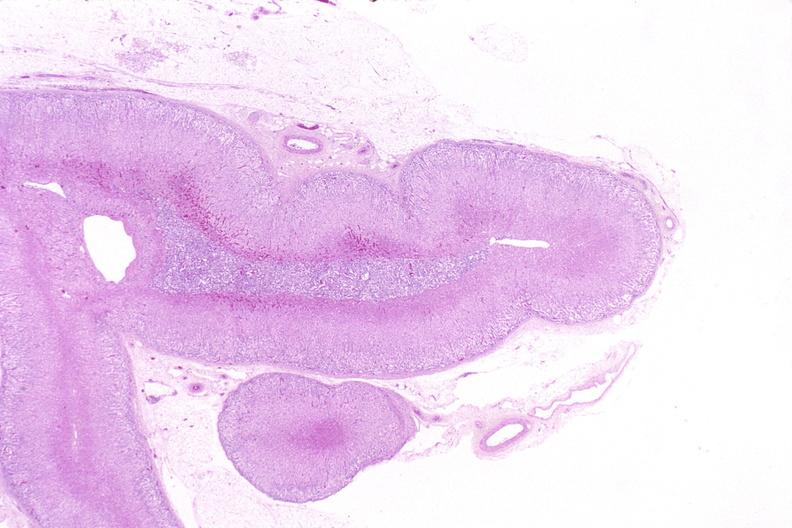s endocrine present?
Answer the question using a single word or phrase. Yes 